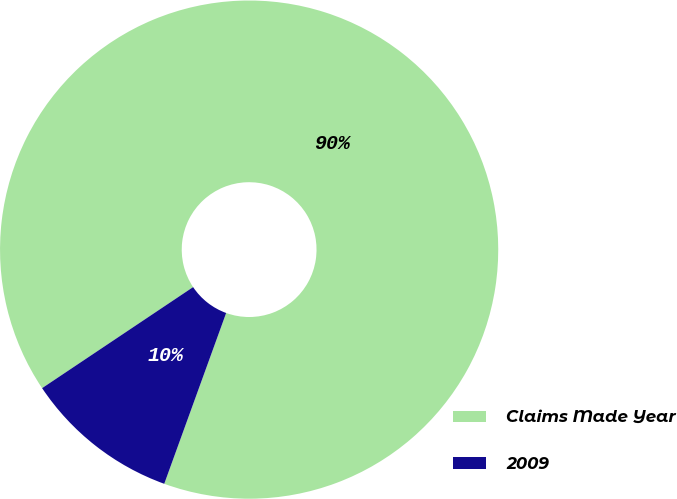Convert chart. <chart><loc_0><loc_0><loc_500><loc_500><pie_chart><fcel>Claims Made Year<fcel>2009<nl><fcel>89.92%<fcel>10.08%<nl></chart> 